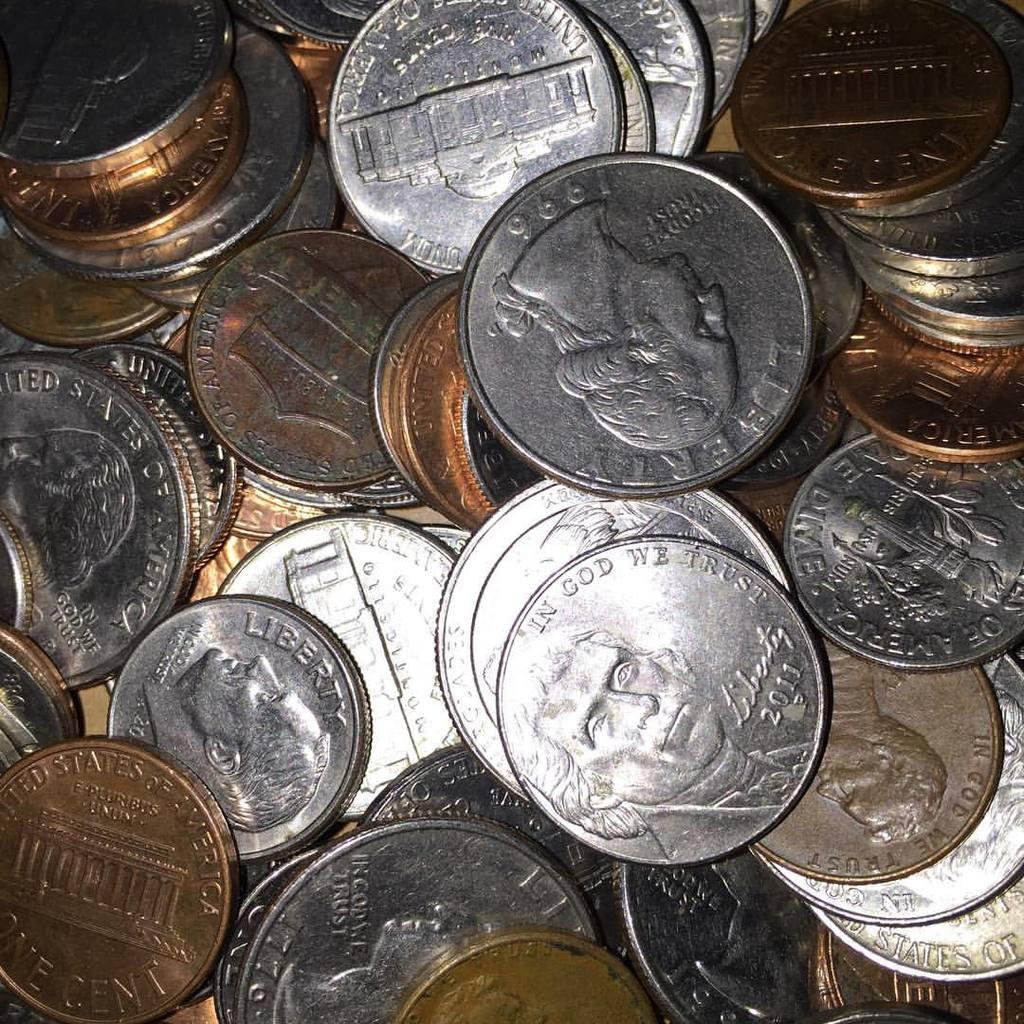<image>
Create a compact narrative representing the image presented. a pile of american coins with a nickle reading in god we trust on top 